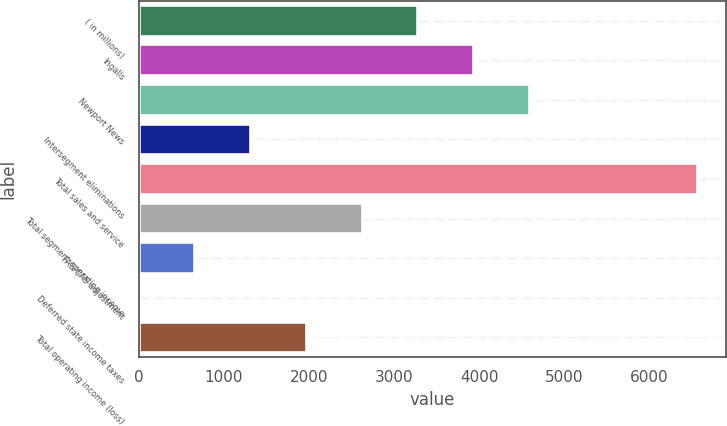<chart> <loc_0><loc_0><loc_500><loc_500><bar_chart><fcel>( in millions)<fcel>Ingalls<fcel>Newport News<fcel>Intersegment eliminations<fcel>Total sales and service<fcel>Total segment operating income<fcel>FAS/CAS adjustment<fcel>Deferred state income taxes<fcel>Total operating income (loss)<nl><fcel>3288<fcel>3945.4<fcel>4602.8<fcel>1315.8<fcel>6575<fcel>2630.6<fcel>658.4<fcel>1<fcel>1973.2<nl></chart> 